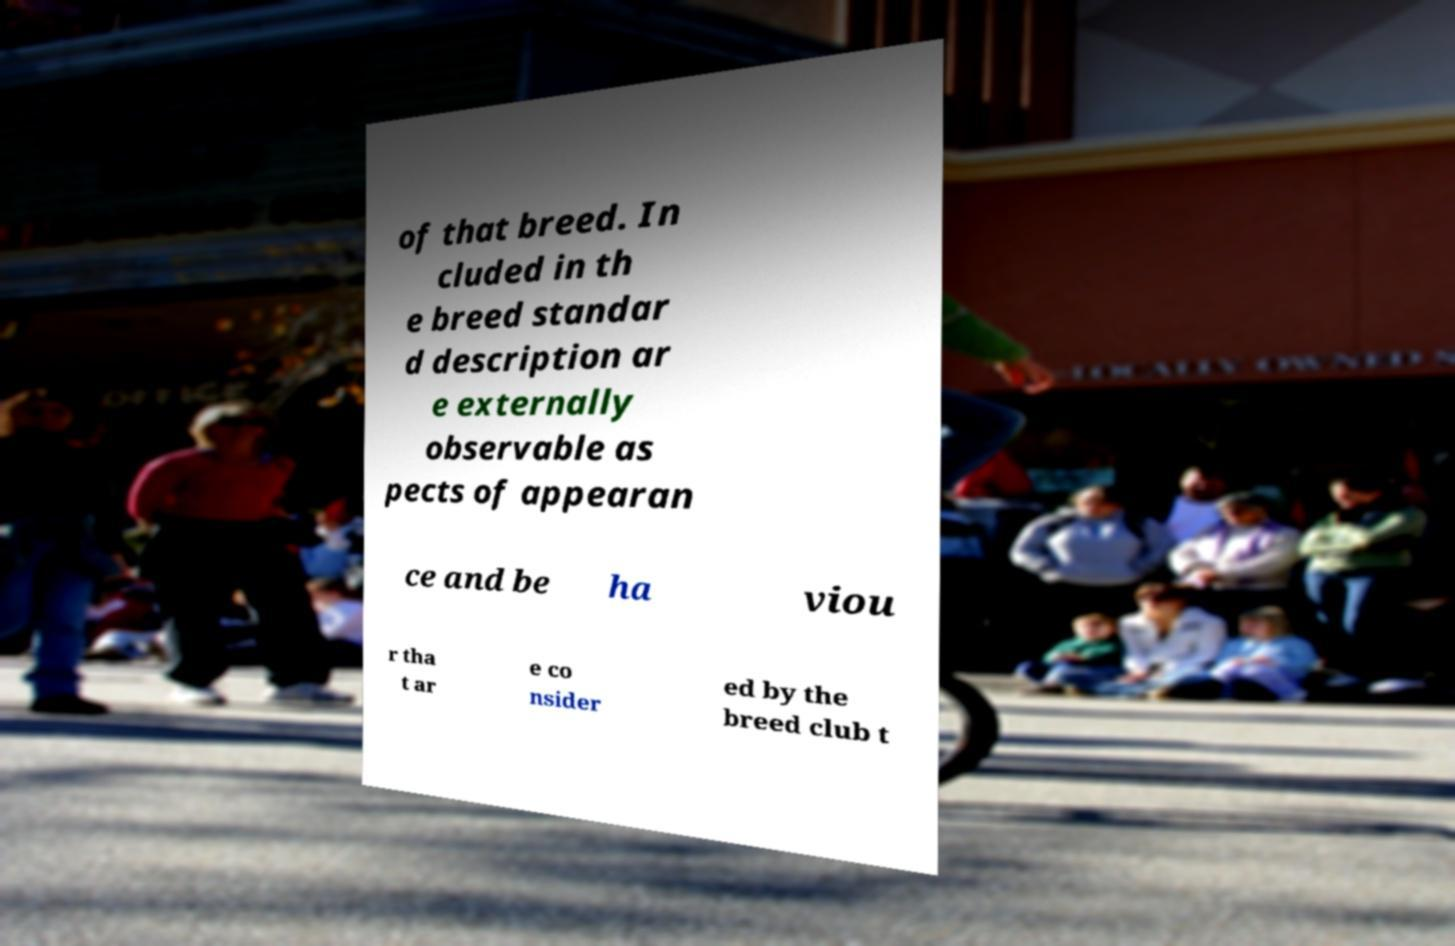Could you extract and type out the text from this image? of that breed. In cluded in th e breed standar d description ar e externally observable as pects of appearan ce and be ha viou r tha t ar e co nsider ed by the breed club t 